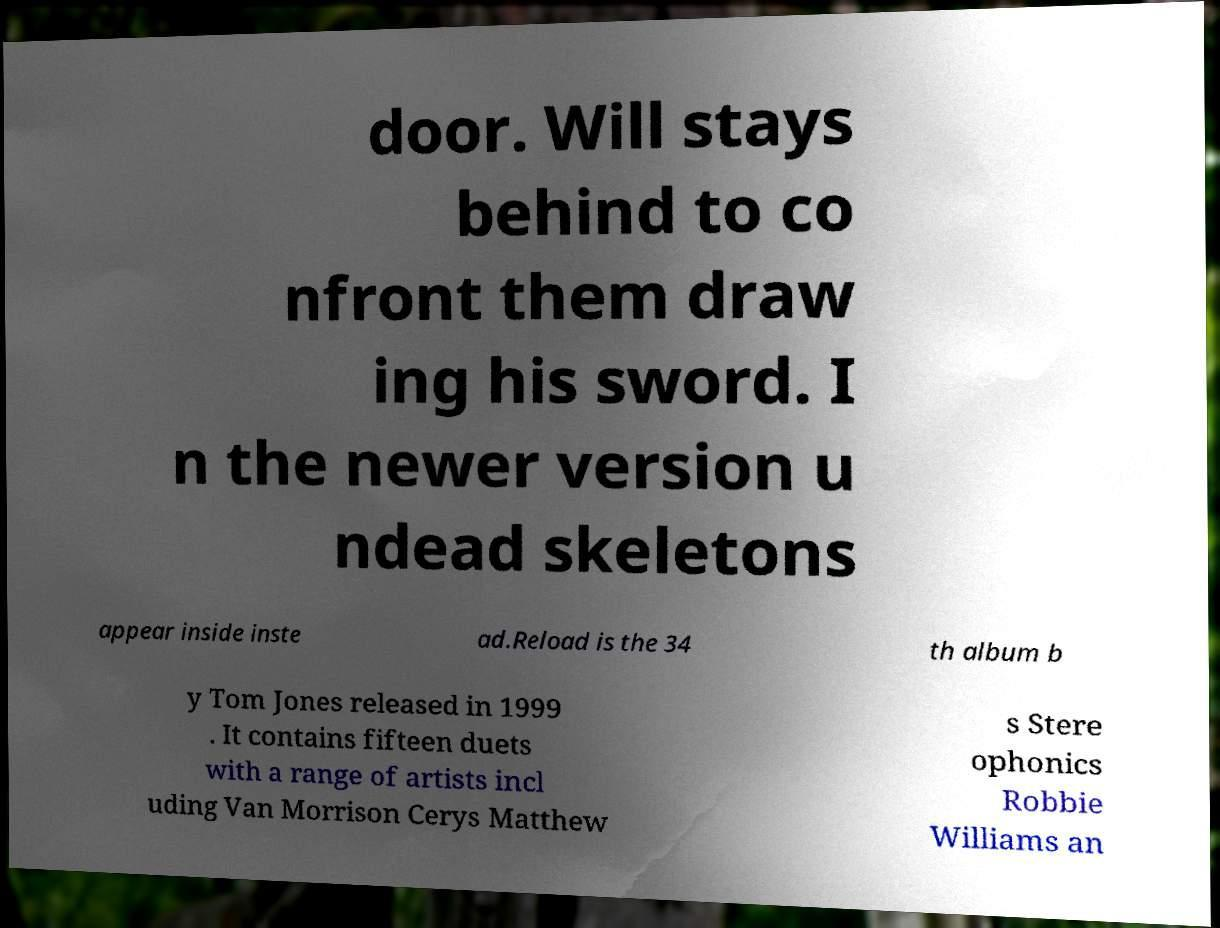What messages or text are displayed in this image? I need them in a readable, typed format. door. Will stays behind to co nfront them draw ing his sword. I n the newer version u ndead skeletons appear inside inste ad.Reload is the 34 th album b y Tom Jones released in 1999 . It contains fifteen duets with a range of artists incl uding Van Morrison Cerys Matthew s Stere ophonics Robbie Williams an 